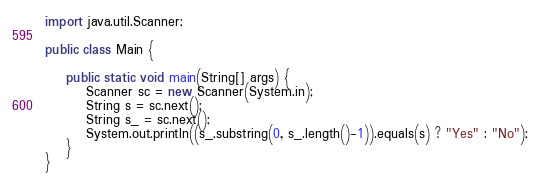Convert code to text. <code><loc_0><loc_0><loc_500><loc_500><_Java_>
import java.util.Scanner;

public class Main {

    public static void main(String[] args) {
        Scanner sc = new Scanner(System.in);
        String s = sc.next();
        String s_ = sc.next();
        System.out.println((s_.substring(0, s_.length()-1)).equals(s) ? "Yes" : "No");
    }
}
</code> 